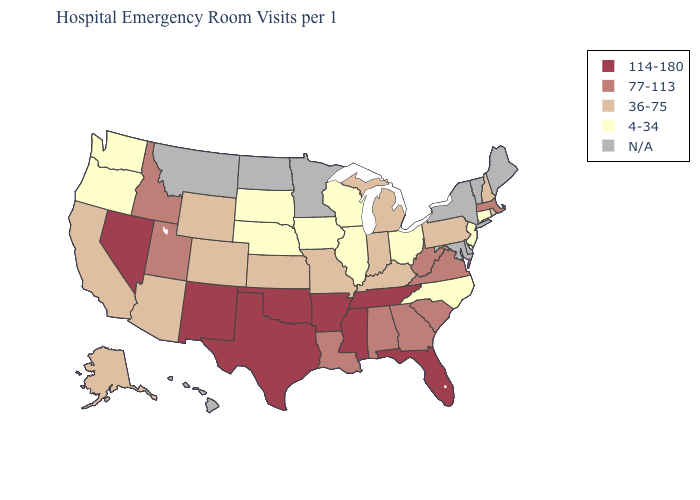What is the highest value in the USA?
Concise answer only. 114-180. Among the states that border Idaho , which have the lowest value?
Short answer required. Oregon, Washington. What is the value of Louisiana?
Be succinct. 77-113. Name the states that have a value in the range 114-180?
Short answer required. Arkansas, Florida, Mississippi, Nevada, New Mexico, Oklahoma, Tennessee, Texas. What is the value of South Carolina?
Keep it brief. 77-113. Which states have the lowest value in the South?
Concise answer only. North Carolina. What is the value of Rhode Island?
Concise answer only. 36-75. Name the states that have a value in the range 4-34?
Concise answer only. Connecticut, Illinois, Iowa, Nebraska, New Jersey, North Carolina, Ohio, Oregon, South Dakota, Washington, Wisconsin. Which states have the lowest value in the USA?
Keep it brief. Connecticut, Illinois, Iowa, Nebraska, New Jersey, North Carolina, Ohio, Oregon, South Dakota, Washington, Wisconsin. Name the states that have a value in the range 114-180?
Give a very brief answer. Arkansas, Florida, Mississippi, Nevada, New Mexico, Oklahoma, Tennessee, Texas. What is the value of Massachusetts?
Short answer required. 77-113. How many symbols are there in the legend?
Give a very brief answer. 5. What is the lowest value in states that border Michigan?
Short answer required. 4-34. 